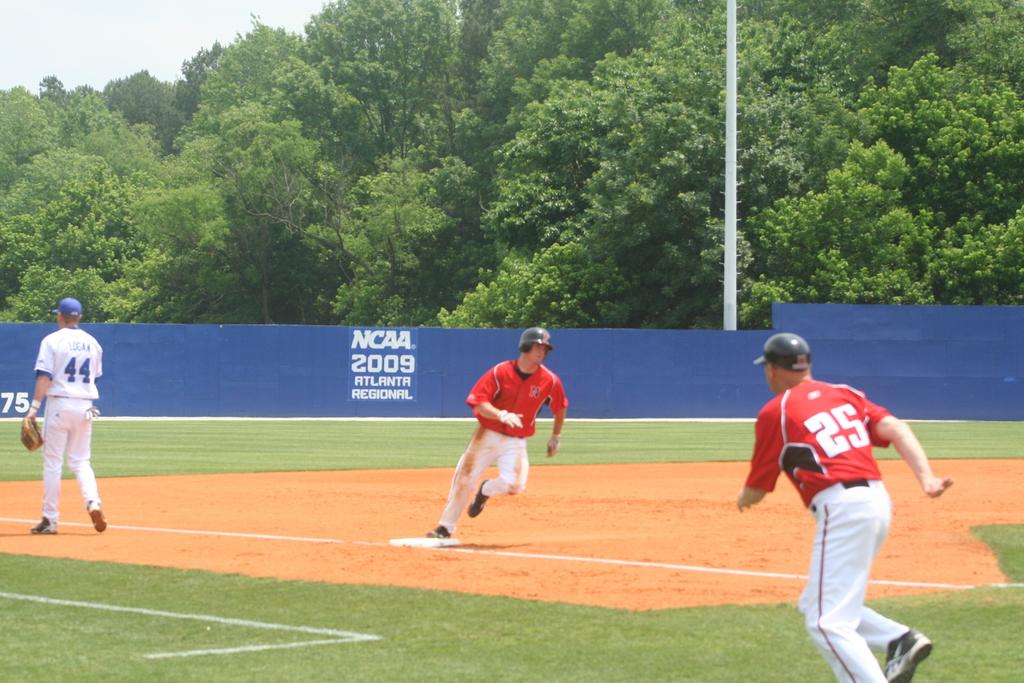Provide a one-sentence caption for the provided image. Players run around the bases at the NCAA 2049 Atlanta Regional game. 